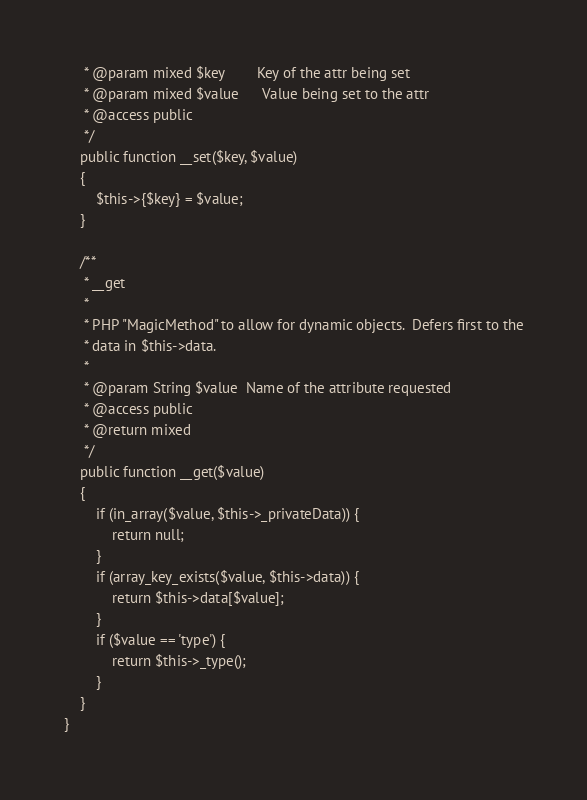Convert code to text. <code><loc_0><loc_0><loc_500><loc_500><_PHP_>     * @param mixed $key        Key of the attr being set
     * @param mixed $value      Value being set to the attr
     * @access public
     */
    public function __set($key, $value)
    {
        $this->{$key} = $value;
    }

    /**
     * __get
     *
     * PHP "MagicMethod" to allow for dynamic objects.  Defers first to the
     * data in $this->data.
     *
     * @param String $value  Name of the attribute requested
     * @access public
     * @return mixed
     */
    public function __get($value)
    {
        if (in_array($value, $this->_privateData)) {
            return null;
        }
        if (array_key_exists($value, $this->data)) {
            return $this->data[$value];
        }
        if ($value == 'type') {
            return $this->_type();
        }
    }
}
</code> 